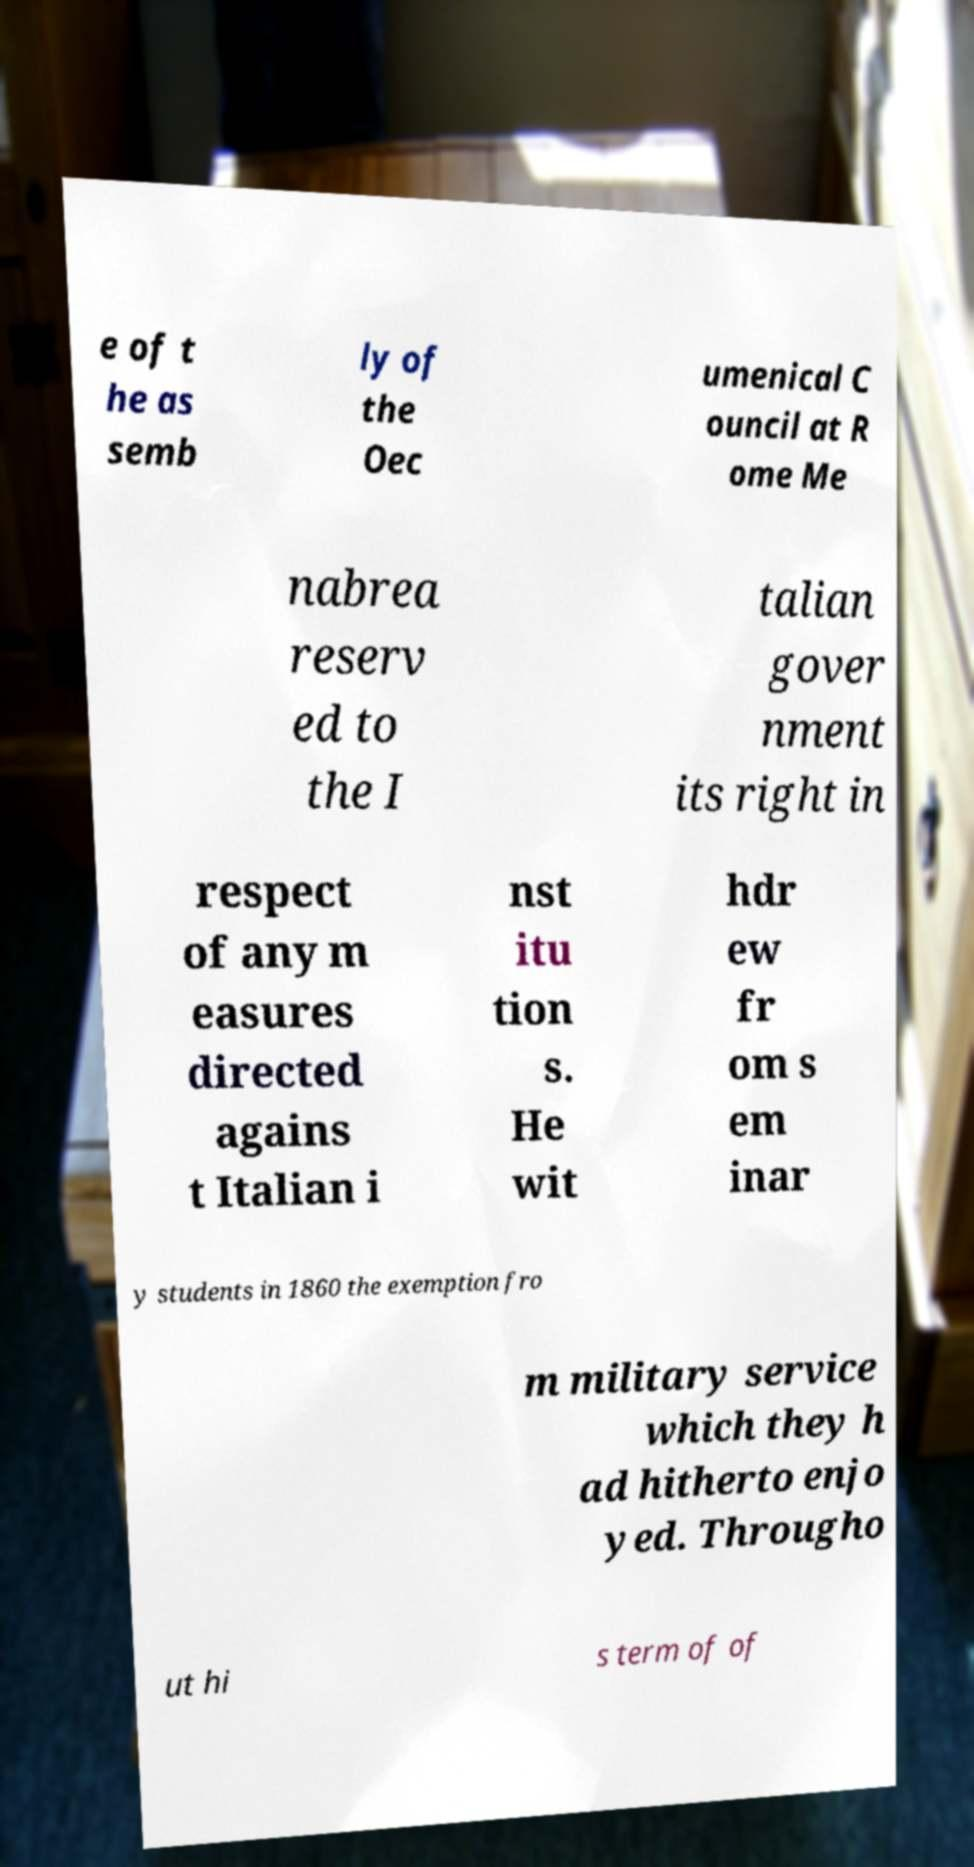Could you extract and type out the text from this image? e of t he as semb ly of the Oec umenical C ouncil at R ome Me nabrea reserv ed to the I talian gover nment its right in respect of any m easures directed agains t Italian i nst itu tion s. He wit hdr ew fr om s em inar y students in 1860 the exemption fro m military service which they h ad hitherto enjo yed. Througho ut hi s term of of 